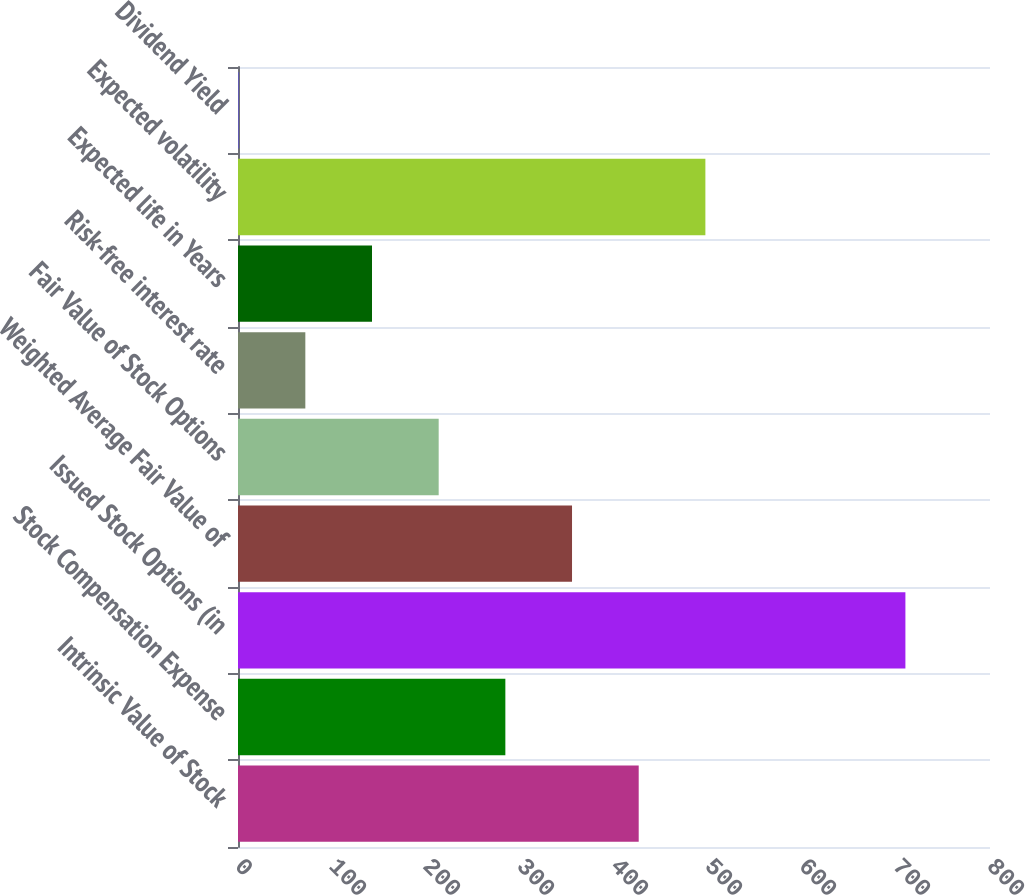<chart> <loc_0><loc_0><loc_500><loc_500><bar_chart><fcel>Intrinsic Value of Stock<fcel>Stock Compensation Expense<fcel>Issued Stock Options (in<fcel>Weighted Average Fair Value of<fcel>Fair Value of Stock Options<fcel>Risk-free interest rate<fcel>Expected life in Years<fcel>Expected volatility<fcel>Dividend Yield<nl><fcel>426.28<fcel>284.42<fcel>710<fcel>355.35<fcel>213.49<fcel>71.63<fcel>142.56<fcel>497.21<fcel>0.7<nl></chart> 